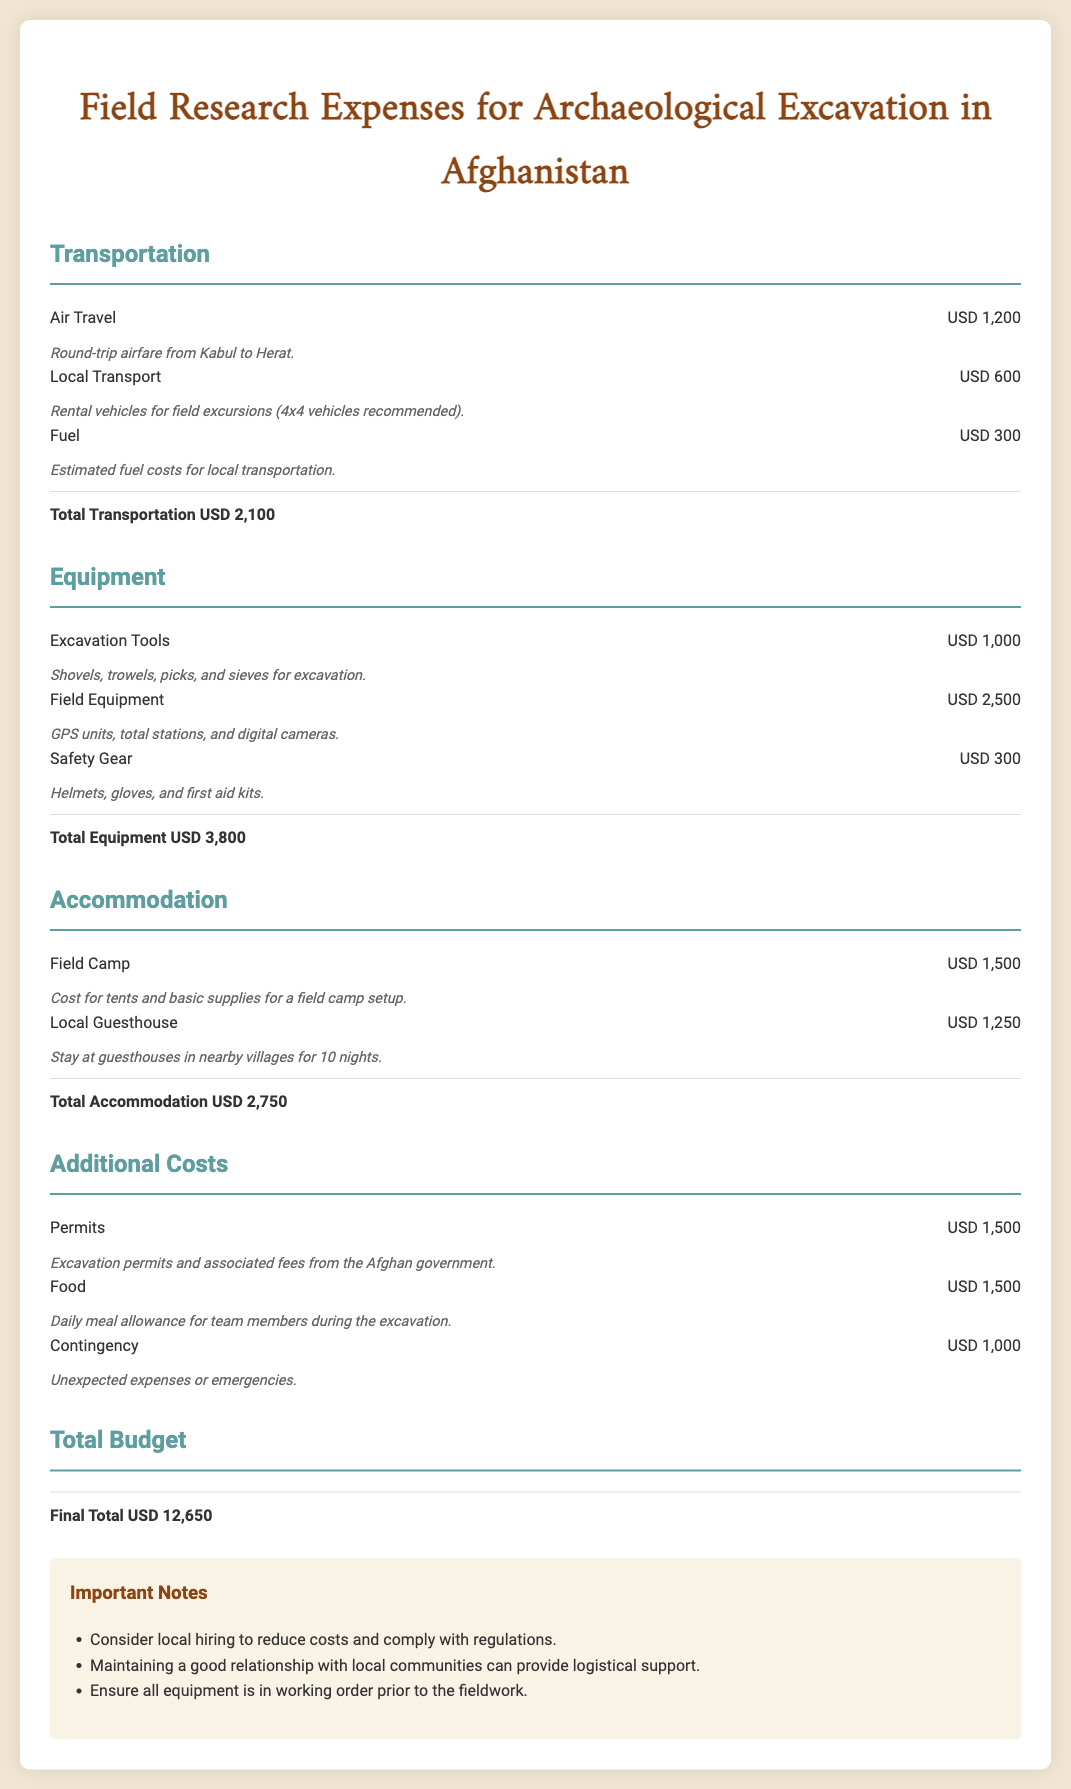what is the total transportation cost? The total transportation cost is listed at the bottom of the transportation section, which adds up to USD 2,100.
Answer: USD 2,100 how much is allocated for excavation tools? The budget for excavation tools is specified in the equipment section, and it amounts to USD 1,000.
Answer: USD 1,000 what are the daily meal allowance costs for the excavation team? The food expenses for the team are stated as part of the additional costs, totaling USD 1,500.
Answer: USD 1,500 what is the total for equipment expenses? The total for equipment is provided at the end of the equipment section, amounting to USD 3,800.
Answer: USD 3,800 how much is budgeted for permits? The document lists the cost for excavation permits as USD 1,500 in the additional costs section.
Answer: USD 1,500 what is the final total budget for the project? The final budget is presented at the end of the document, which sums all expenses to USD 12,650.
Answer: USD 12,650 how much is allocated for local guesthouse accommodation? The budget for staying at local guesthouses is specified as USD 1,250 in the accommodation section.
Answer: USD 1,250 what is included in the safety gear budget? The safety gear budget includes helmets, gloves, and first aid kits, costing USD 300 as stated in the equipment section.
Answer: USD 300 how many nights does the local guesthouse accommodate the team? The number of nights specified for staying at the guesthouse is 10 nights according to the description in the accommodation section.
Answer: 10 nights 